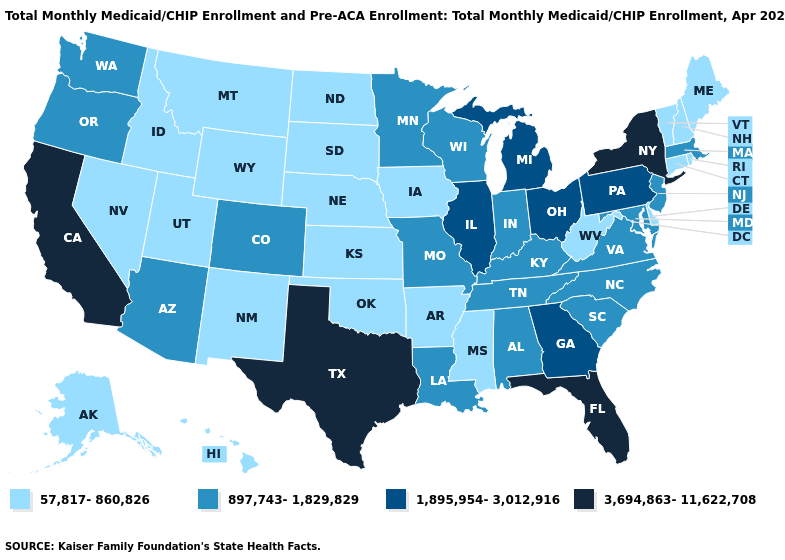Name the states that have a value in the range 1,895,954-3,012,916?
Keep it brief. Georgia, Illinois, Michigan, Ohio, Pennsylvania. What is the value of South Dakota?
Write a very short answer. 57,817-860,826. What is the value of Louisiana?
Short answer required. 897,743-1,829,829. How many symbols are there in the legend?
Be succinct. 4. Name the states that have a value in the range 897,743-1,829,829?
Concise answer only. Alabama, Arizona, Colorado, Indiana, Kentucky, Louisiana, Maryland, Massachusetts, Minnesota, Missouri, New Jersey, North Carolina, Oregon, South Carolina, Tennessee, Virginia, Washington, Wisconsin. Does Florida have the highest value in the USA?
Be succinct. Yes. Does Minnesota have a lower value than Maryland?
Answer briefly. No. What is the highest value in states that border Virginia?
Write a very short answer. 897,743-1,829,829. Name the states that have a value in the range 3,694,863-11,622,708?
Short answer required. California, Florida, New York, Texas. Does Pennsylvania have the same value as Texas?
Concise answer only. No. What is the value of South Dakota?
Concise answer only. 57,817-860,826. How many symbols are there in the legend?
Give a very brief answer. 4. Among the states that border Nevada , which have the lowest value?
Short answer required. Idaho, Utah. What is the lowest value in the USA?
Short answer required. 57,817-860,826. Among the states that border Mississippi , which have the lowest value?
Concise answer only. Arkansas. 